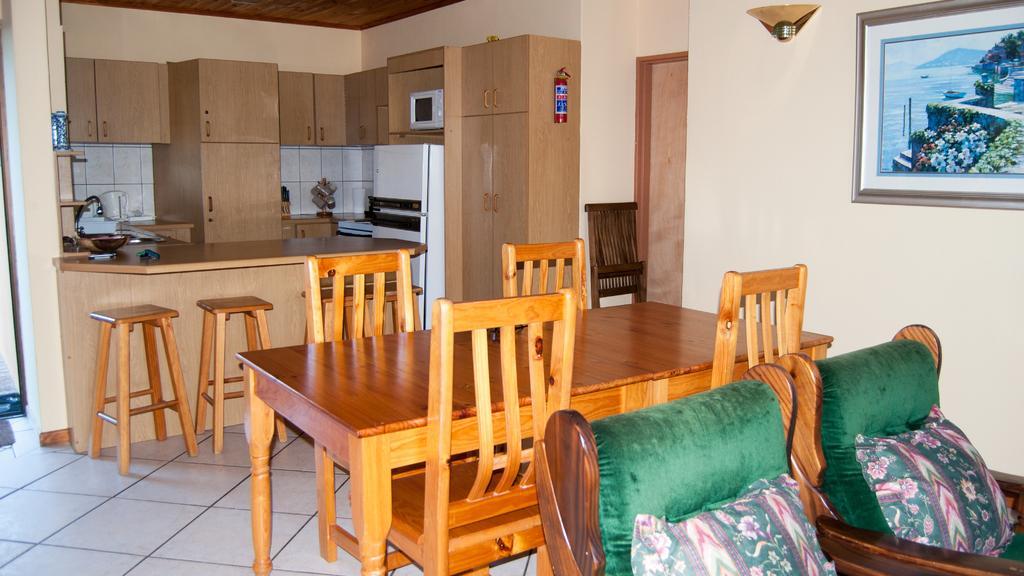How would you summarize this image in a sentence or two? There are sofas at the bottom side of the image and there are chairs, stools, and a table in the center of the image and there is a portrait on the wall, there is a lamp at the top side and there are cupboards, kitchenware, and a refrigerator in the background area of the image. 